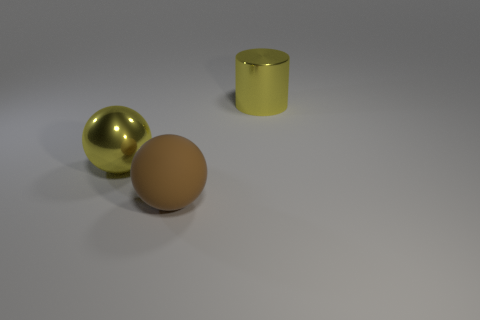What is the shape of the large object that is both behind the brown rubber thing and on the right side of the big yellow sphere?
Offer a terse response. Cylinder. What number of other rubber objects are the same shape as the brown object?
Offer a terse response. 0. Do the big cylinder and the large metal ball have the same color?
Your answer should be compact. Yes. Are there any metal cylinders of the same color as the large metal sphere?
Your response must be concise. Yes. Are the yellow thing to the left of the metal cylinder and the big yellow thing on the right side of the big metallic sphere made of the same material?
Your answer should be very brief. Yes. What is the color of the large shiny cylinder?
Give a very brief answer. Yellow. What size is the metallic thing left of the yellow object that is right of the shiny thing that is left of the big yellow metal cylinder?
Your response must be concise. Large. What number of other things are there of the same size as the metal cylinder?
Your response must be concise. 2. How many big yellow cylinders have the same material as the big yellow ball?
Give a very brief answer. 1. The yellow metal thing in front of the large yellow cylinder has what shape?
Your response must be concise. Sphere. 